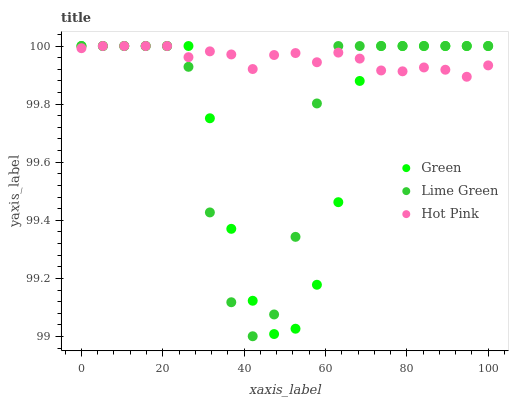Does Green have the minimum area under the curve?
Answer yes or no. Yes. Does Hot Pink have the maximum area under the curve?
Answer yes or no. Yes. Does Hot Pink have the minimum area under the curve?
Answer yes or no. No. Does Green have the maximum area under the curve?
Answer yes or no. No. Is Hot Pink the smoothest?
Answer yes or no. Yes. Is Lime Green the roughest?
Answer yes or no. Yes. Is Green the smoothest?
Answer yes or no. No. Is Green the roughest?
Answer yes or no. No. Does Lime Green have the lowest value?
Answer yes or no. Yes. Does Green have the lowest value?
Answer yes or no. No. Does Green have the highest value?
Answer yes or no. Yes. Does Lime Green intersect Hot Pink?
Answer yes or no. Yes. Is Lime Green less than Hot Pink?
Answer yes or no. No. Is Lime Green greater than Hot Pink?
Answer yes or no. No. 